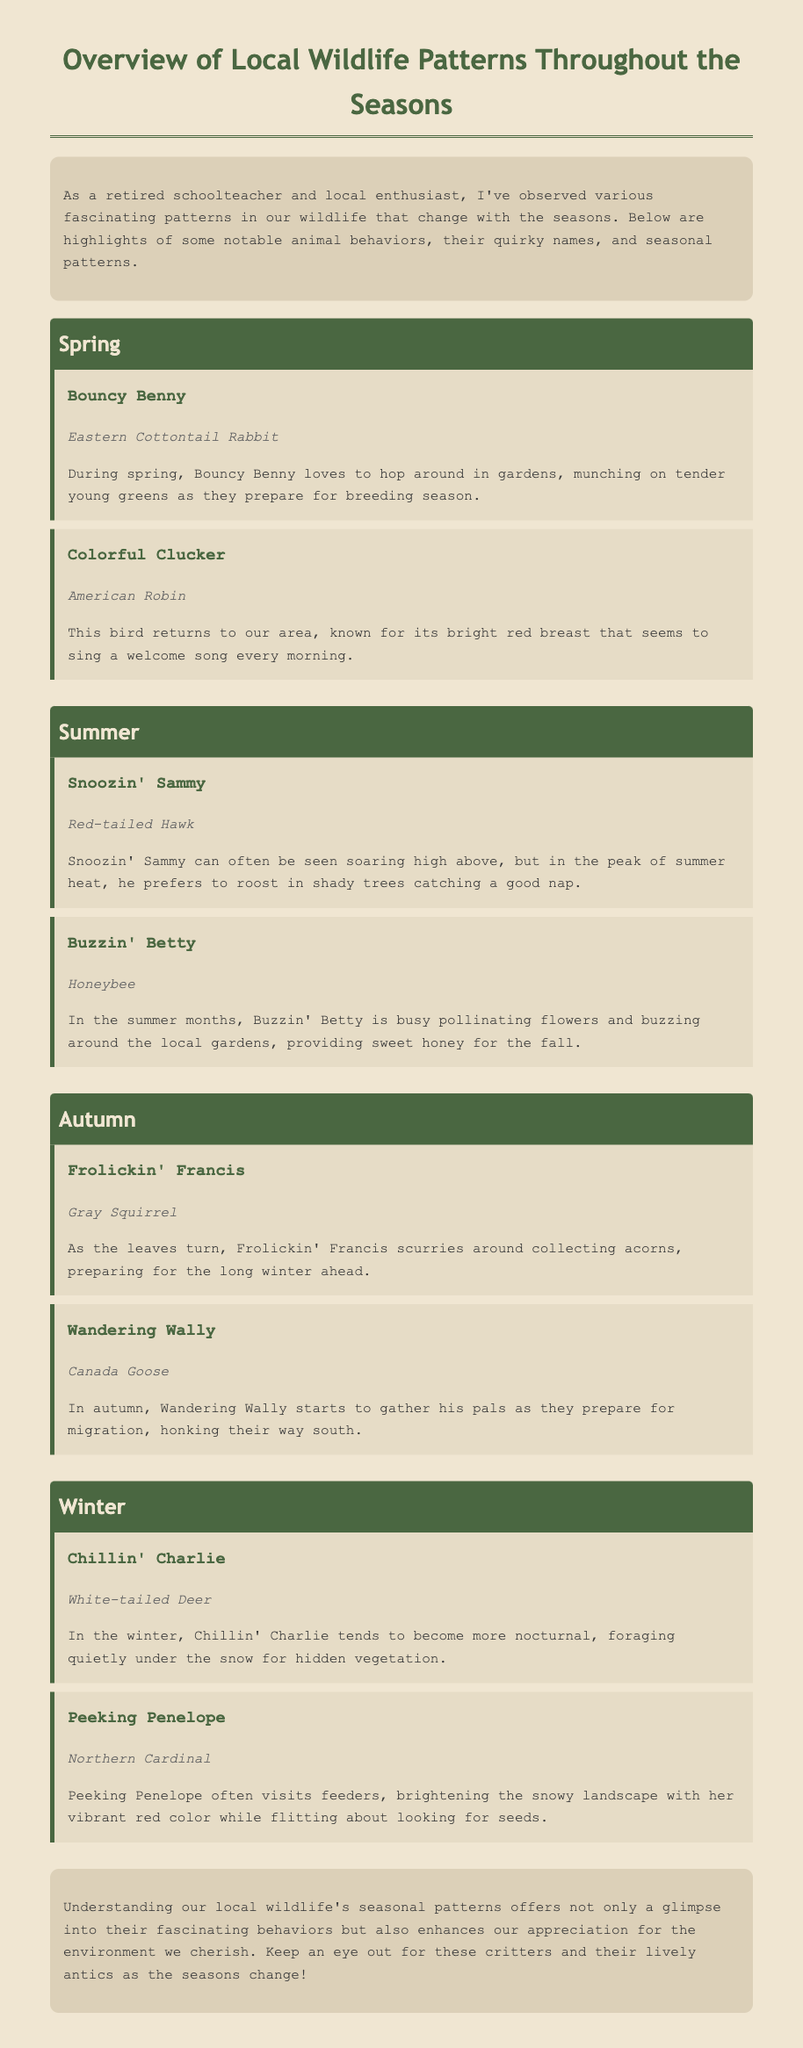What is the name of the rabbit in spring? The memo introduces the Eastern Cottontail Rabbit as "Bouncy Benny" during the spring season.
Answer: Bouncy Benny What seasonal behavior does "Colorful Clucker" exhibit? The American Robin, known as "Colorful Clucker," is described to return and sing a welcome song in spring.
Answer: Sings a welcome song Which animal collects acorns in autumn? The memo states that "Frolickin' Francis," the Gray Squirrel, collects acorns as the leaves turn.
Answer: Gray Squirrel What is "Chillin' Charlie" doing in winter? "Chillin' Charlie," the White-tailed Deer, forages quietly under the snow for vegetation in winter.
Answer: Foraging under the snow How does "Snoozin' Sammy" behave in summer? The Red-tailed Hawk, referred to as "Snoozin' Sammy," prefers to roost in shady trees to nap during peak summer heat.
Answer: Roosts in shady trees What animal starts to gather for migration in autumn? The memo mentions that "Wandering Wally," the Canada Goose, gathers his pals to prepare for migration in autumn.
Answer: Canada Goose How does the document enhance appreciation for the environment? It emphasizes understanding local wildlife's seasonal patterns to enhance appreciation for the environment.
Answer: Enhances appreciation What color is "Peeking Penelope"? The Northern Cardinal is described as having vibrant red color during winter as "Peeking Penelope."
Answer: Vibrant red color 